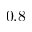Convert formula to latex. <formula><loc_0><loc_0><loc_500><loc_500>0 . 8</formula> 